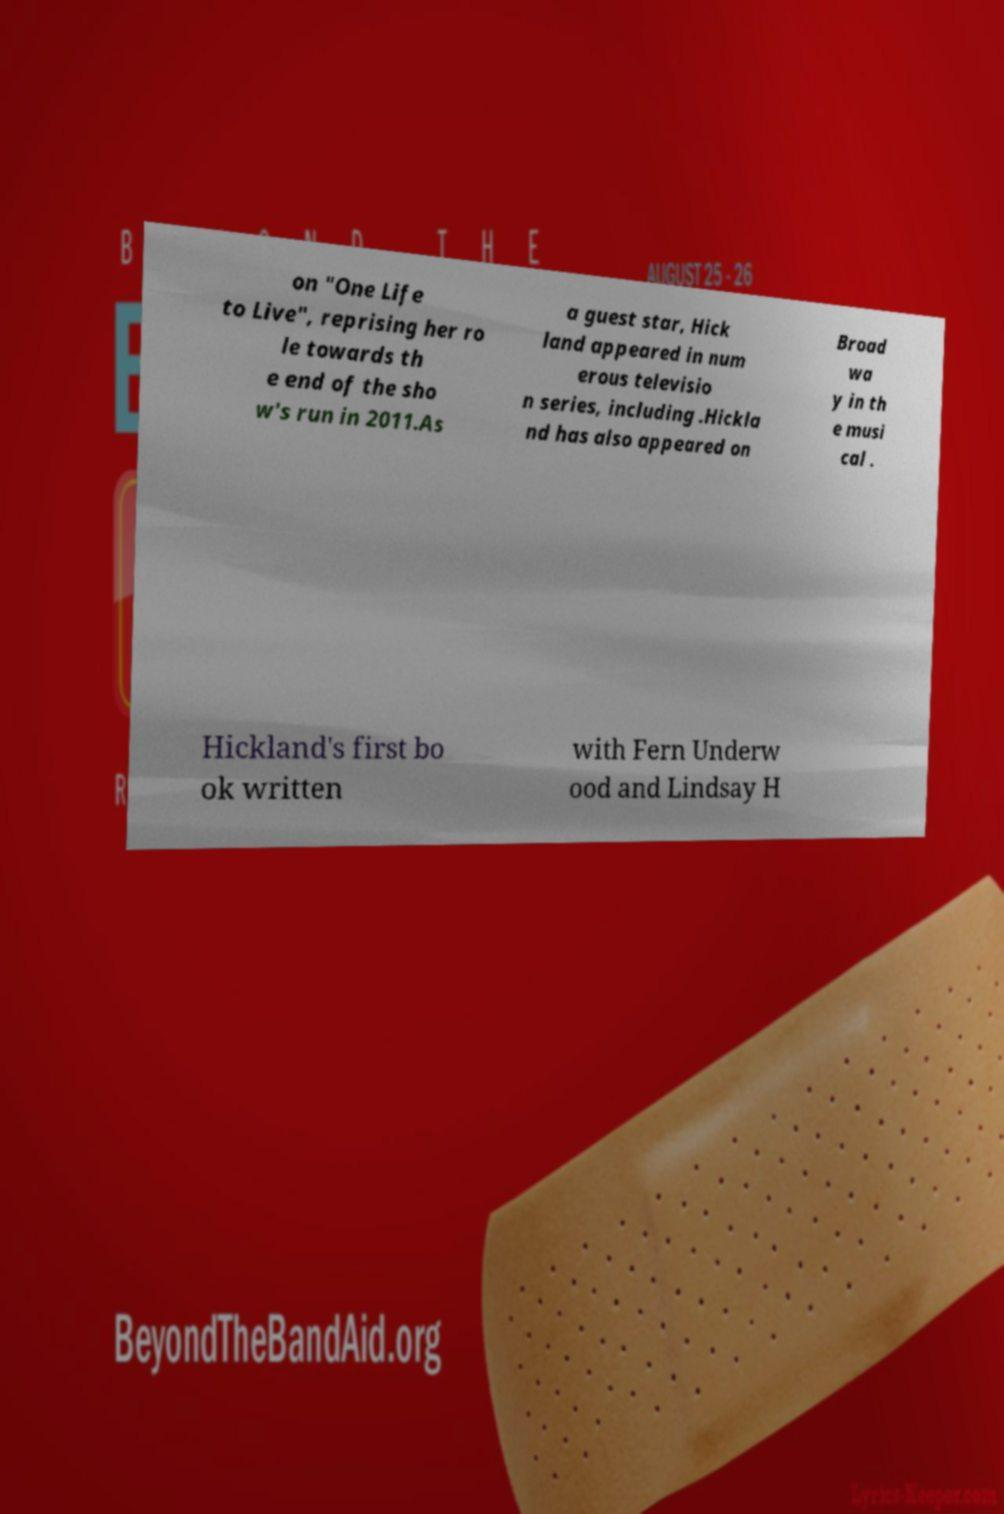For documentation purposes, I need the text within this image transcribed. Could you provide that? on "One Life to Live", reprising her ro le towards th e end of the sho w's run in 2011.As a guest star, Hick land appeared in num erous televisio n series, including .Hickla nd has also appeared on Broad wa y in th e musi cal . Hickland's first bo ok written with Fern Underw ood and Lindsay H 